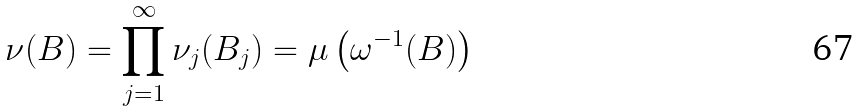<formula> <loc_0><loc_0><loc_500><loc_500>\nu ( B ) = \prod _ { j = 1 } ^ { \infty } \nu _ { j } ( B _ { j } ) = \mu \left ( \omega ^ { - 1 } ( B ) \right )</formula> 